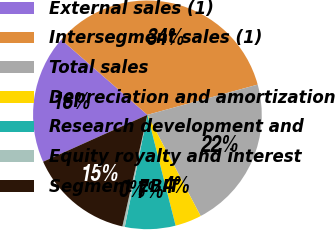Convert chart. <chart><loc_0><loc_0><loc_500><loc_500><pie_chart><fcel>External sales (1)<fcel>Intersegment sales (1)<fcel>Total sales<fcel>Depreciation and amortization<fcel>Research development and<fcel>Equity royalty and interest<fcel>Segment EBIT<nl><fcel>18.15%<fcel>34.32%<fcel>21.55%<fcel>3.74%<fcel>7.14%<fcel>0.34%<fcel>14.76%<nl></chart> 